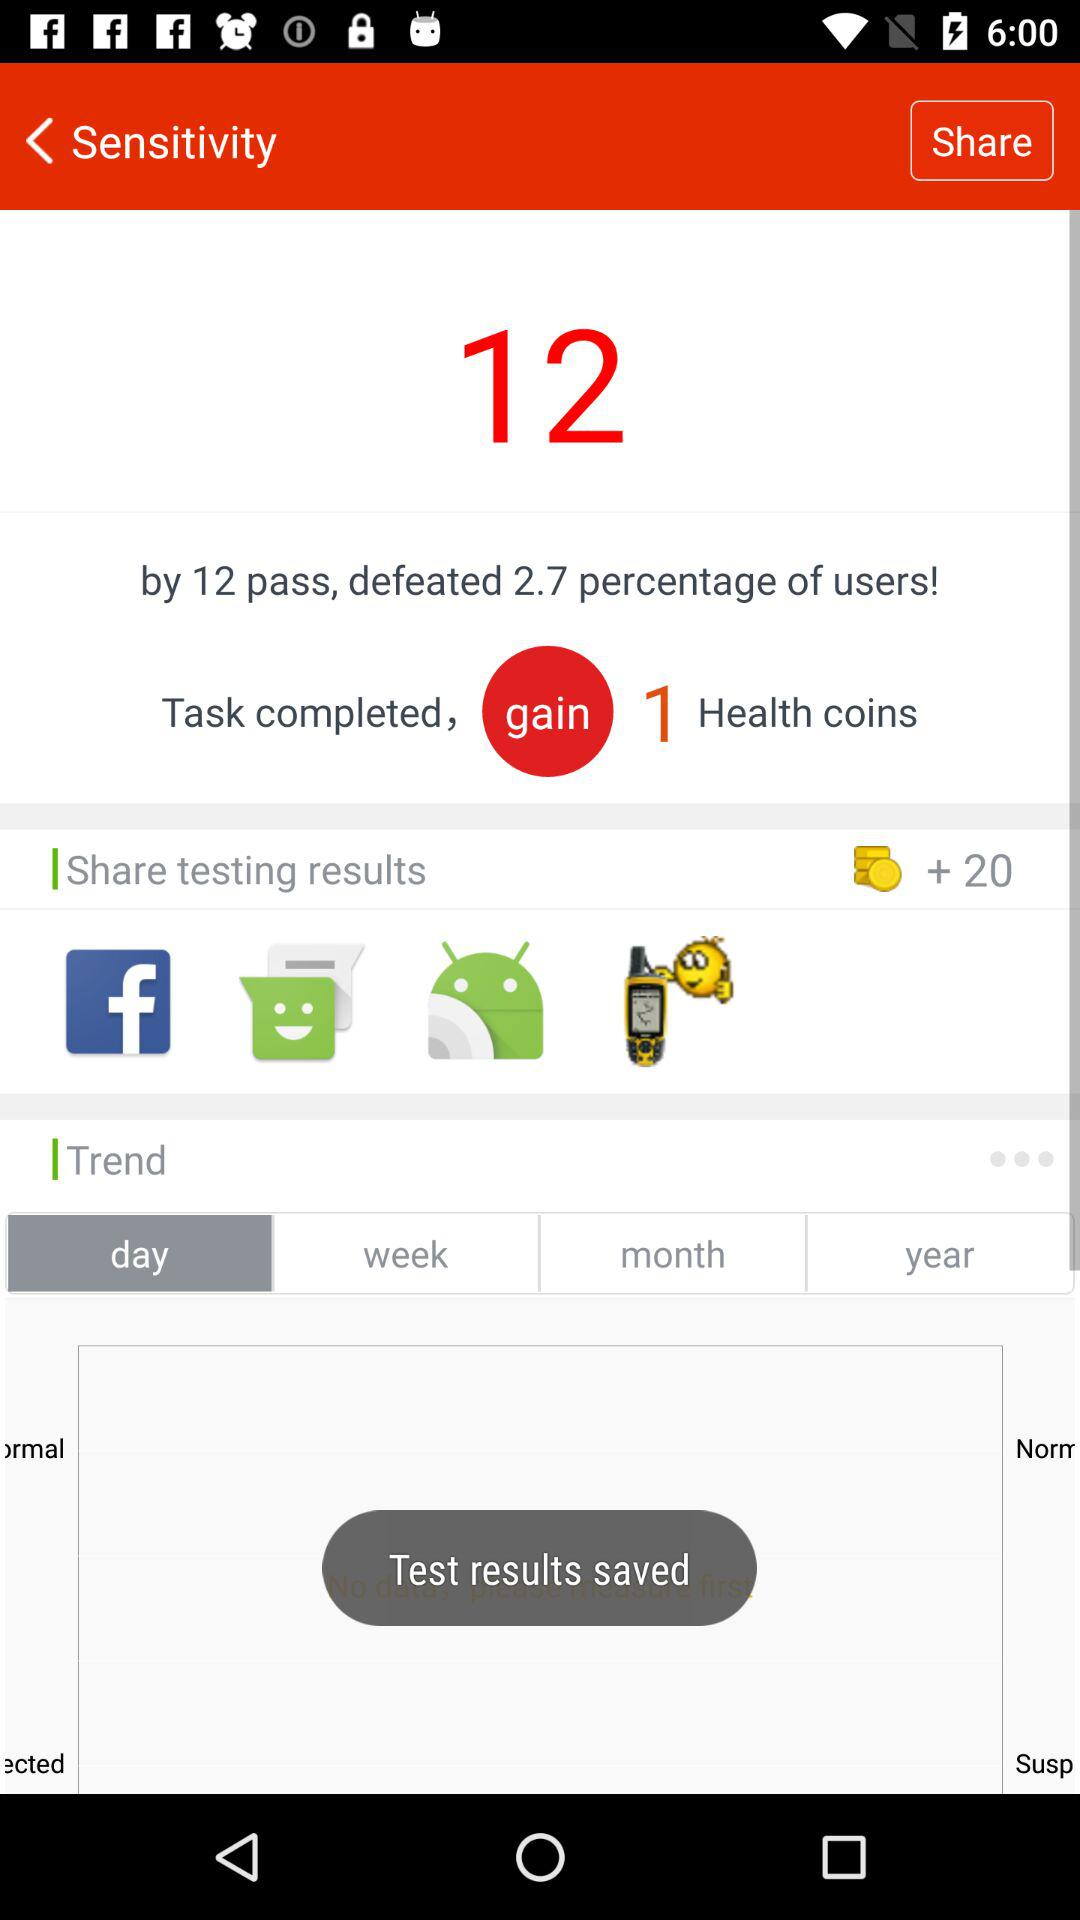What does 'defeated 2.7 percentage of users' imply in the context of the image? The phrase suggests that by completing those 12 tasks, you performed better than 2.7% of the user base, hinting at the competitive aspect of the application. 